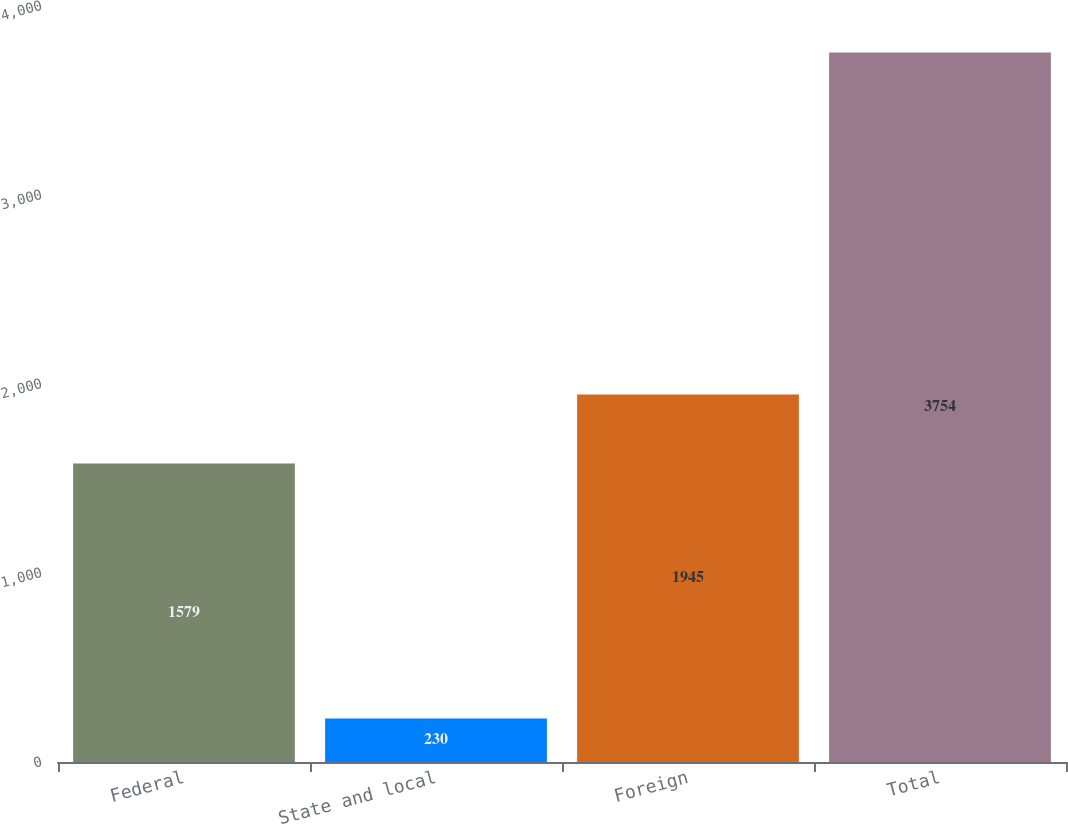Convert chart. <chart><loc_0><loc_0><loc_500><loc_500><bar_chart><fcel>Federal<fcel>State and local<fcel>Foreign<fcel>Total<nl><fcel>1579<fcel>230<fcel>1945<fcel>3754<nl></chart> 